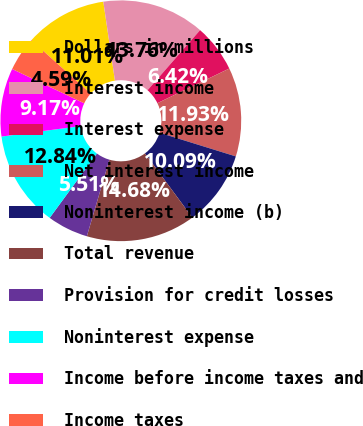Convert chart. <chart><loc_0><loc_0><loc_500><loc_500><pie_chart><fcel>Dollars in millions<fcel>Interest income<fcel>Interest expense<fcel>Net interest income<fcel>Noninterest income (b)<fcel>Total revenue<fcel>Provision for credit losses<fcel>Noninterest expense<fcel>Income before income taxes and<fcel>Income taxes<nl><fcel>11.01%<fcel>13.76%<fcel>6.42%<fcel>11.93%<fcel>10.09%<fcel>14.68%<fcel>5.51%<fcel>12.84%<fcel>9.17%<fcel>4.59%<nl></chart> 